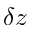Convert formula to latex. <formula><loc_0><loc_0><loc_500><loc_500>\delta z</formula> 